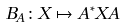Convert formula to latex. <formula><loc_0><loc_0><loc_500><loc_500>B _ { A } \colon X \mapsto A ^ { * } X A</formula> 